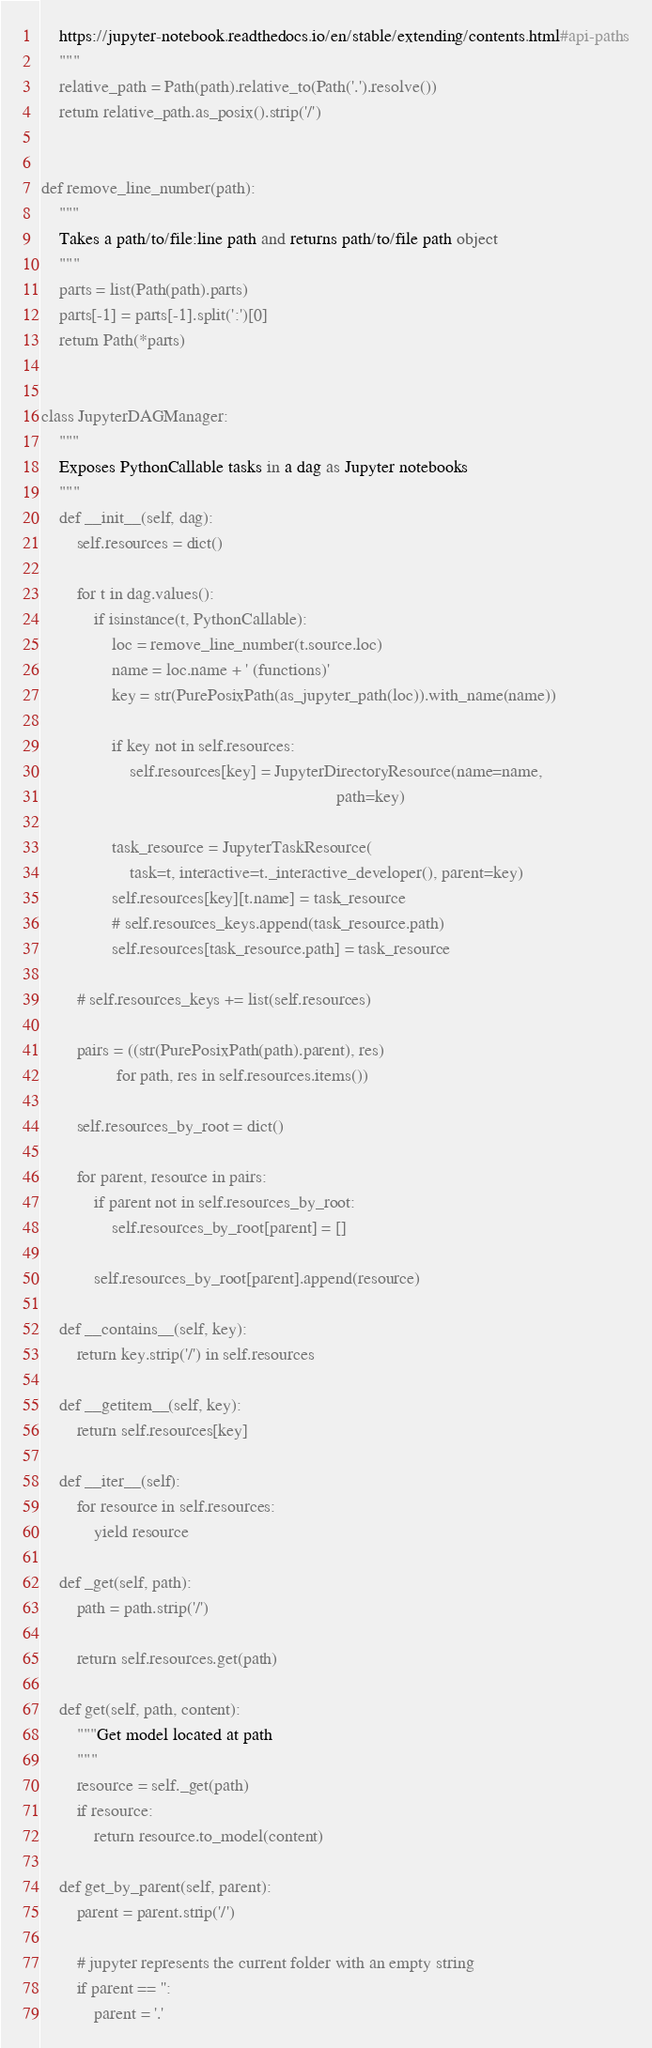<code> <loc_0><loc_0><loc_500><loc_500><_Python_>    https://jupyter-notebook.readthedocs.io/en/stable/extending/contents.html#api-paths
    """
    relative_path = Path(path).relative_to(Path('.').resolve())
    return relative_path.as_posix().strip('/')


def remove_line_number(path):
    """
    Takes a path/to/file:line path and returns path/to/file path object
    """
    parts = list(Path(path).parts)
    parts[-1] = parts[-1].split(':')[0]
    return Path(*parts)


class JupyterDAGManager:
    """
    Exposes PythonCallable tasks in a dag as Jupyter notebooks
    """
    def __init__(self, dag):
        self.resources = dict()

        for t in dag.values():
            if isinstance(t, PythonCallable):
                loc = remove_line_number(t.source.loc)
                name = loc.name + ' (functions)'
                key = str(PurePosixPath(as_jupyter_path(loc)).with_name(name))

                if key not in self.resources:
                    self.resources[key] = JupyterDirectoryResource(name=name,
                                                                   path=key)

                task_resource = JupyterTaskResource(
                    task=t, interactive=t._interactive_developer(), parent=key)
                self.resources[key][t.name] = task_resource
                # self.resources_keys.append(task_resource.path)
                self.resources[task_resource.path] = task_resource

        # self.resources_keys += list(self.resources)

        pairs = ((str(PurePosixPath(path).parent), res)
                 for path, res in self.resources.items())

        self.resources_by_root = dict()

        for parent, resource in pairs:
            if parent not in self.resources_by_root:
                self.resources_by_root[parent] = []

            self.resources_by_root[parent].append(resource)

    def __contains__(self, key):
        return key.strip('/') in self.resources

    def __getitem__(self, key):
        return self.resources[key]

    def __iter__(self):
        for resource in self.resources:
            yield resource

    def _get(self, path):
        path = path.strip('/')

        return self.resources.get(path)

    def get(self, path, content):
        """Get model located at path
        """
        resource = self._get(path)
        if resource:
            return resource.to_model(content)

    def get_by_parent(self, parent):
        parent = parent.strip('/')

        # jupyter represents the current folder with an empty string
        if parent == '':
            parent = '.'
</code> 